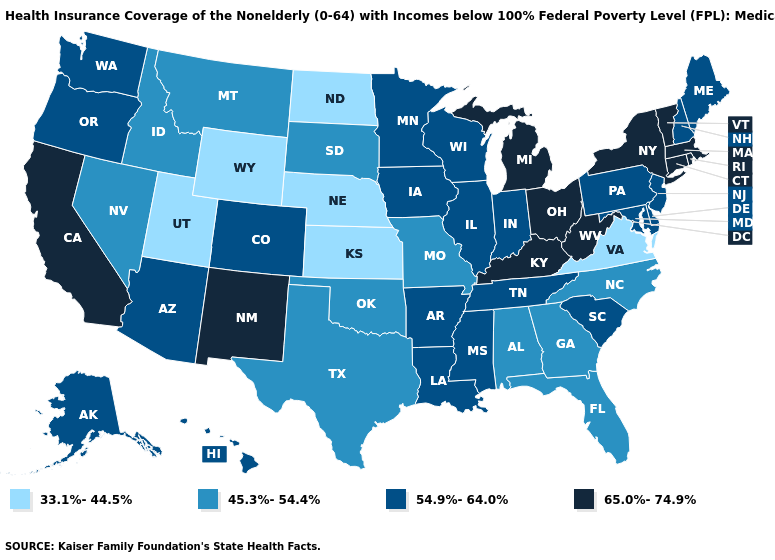What is the value of Kansas?
Answer briefly. 33.1%-44.5%. Does New Mexico have a lower value than Alaska?
Concise answer only. No. What is the value of California?
Concise answer only. 65.0%-74.9%. What is the value of North Carolina?
Quick response, please. 45.3%-54.4%. What is the value of North Carolina?
Quick response, please. 45.3%-54.4%. Is the legend a continuous bar?
Give a very brief answer. No. Does West Virginia have the highest value in the South?
Write a very short answer. Yes. Name the states that have a value in the range 45.3%-54.4%?
Write a very short answer. Alabama, Florida, Georgia, Idaho, Missouri, Montana, Nevada, North Carolina, Oklahoma, South Dakota, Texas. What is the value of Oregon?
Write a very short answer. 54.9%-64.0%. What is the value of Texas?
Write a very short answer. 45.3%-54.4%. Which states have the highest value in the USA?
Short answer required. California, Connecticut, Kentucky, Massachusetts, Michigan, New Mexico, New York, Ohio, Rhode Island, Vermont, West Virginia. What is the lowest value in states that border Idaho?
Quick response, please. 33.1%-44.5%. What is the value of Massachusetts?
Quick response, please. 65.0%-74.9%. Does Florida have the lowest value in the USA?
Quick response, please. No. What is the value of Arizona?
Quick response, please. 54.9%-64.0%. 